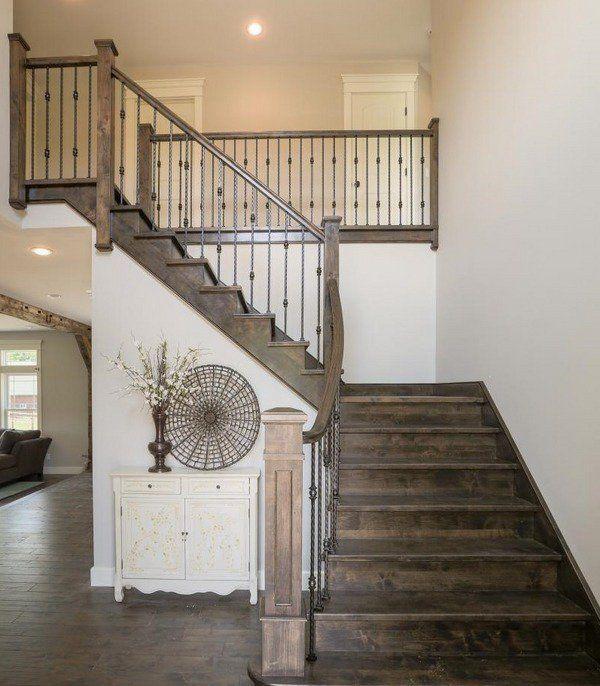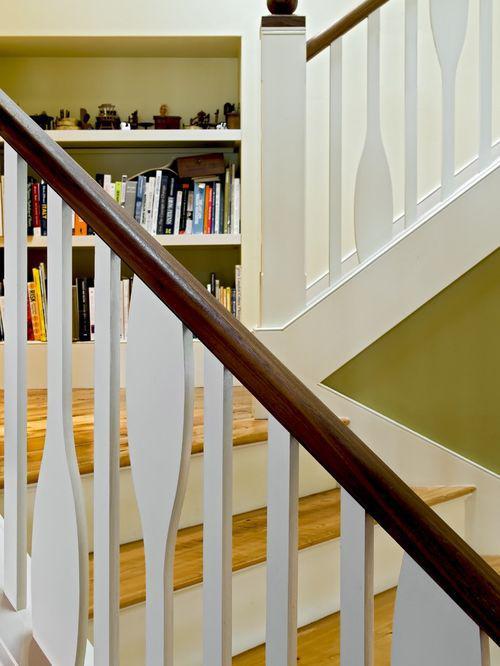The first image is the image on the left, the second image is the image on the right. Examine the images to the left and right. Is the description "The left image shows a curving staircase with a curving rail on the right side." accurate? Answer yes or no. No. The first image is the image on the left, the second image is the image on the right. Considering the images on both sides, is "One staircase's railing is white and the other's is black." valid? Answer yes or no. Yes. 